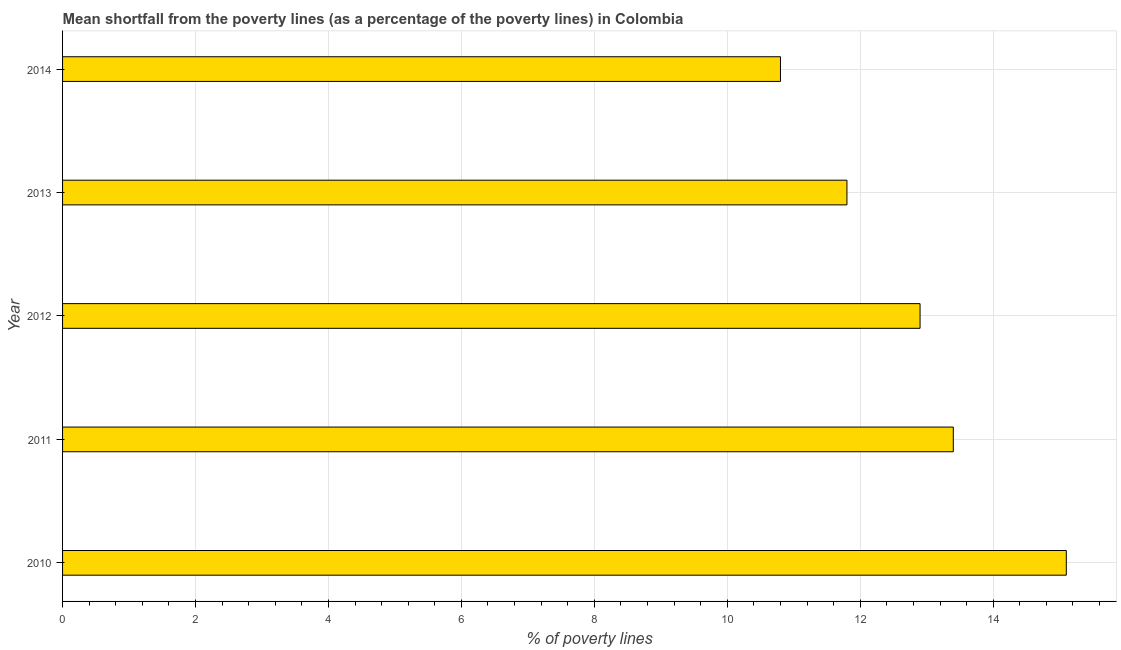What is the title of the graph?
Make the answer very short. Mean shortfall from the poverty lines (as a percentage of the poverty lines) in Colombia. What is the label or title of the X-axis?
Your response must be concise. % of poverty lines. What is the poverty gap at national poverty lines in 2012?
Ensure brevity in your answer.  12.9. In which year was the poverty gap at national poverty lines maximum?
Make the answer very short. 2010. What is the sum of the poverty gap at national poverty lines?
Keep it short and to the point. 64. What is the difference between the poverty gap at national poverty lines in 2012 and 2013?
Offer a terse response. 1.1. What is the average poverty gap at national poverty lines per year?
Give a very brief answer. 12.8. Do a majority of the years between 2010 and 2013 (inclusive) have poverty gap at national poverty lines greater than 3.6 %?
Offer a terse response. Yes. What is the ratio of the poverty gap at national poverty lines in 2011 to that in 2014?
Give a very brief answer. 1.24. What is the difference between the highest and the second highest poverty gap at national poverty lines?
Your answer should be very brief. 1.7. Is the sum of the poverty gap at national poverty lines in 2010 and 2011 greater than the maximum poverty gap at national poverty lines across all years?
Your answer should be compact. Yes. What is the difference between the highest and the lowest poverty gap at national poverty lines?
Give a very brief answer. 4.3. How many bars are there?
Provide a succinct answer. 5. How many years are there in the graph?
Provide a succinct answer. 5. What is the % of poverty lines in 2011?
Provide a succinct answer. 13.4. What is the % of poverty lines of 2012?
Your response must be concise. 12.9. What is the difference between the % of poverty lines in 2010 and 2012?
Your response must be concise. 2.2. What is the difference between the % of poverty lines in 2010 and 2014?
Ensure brevity in your answer.  4.3. What is the difference between the % of poverty lines in 2011 and 2012?
Your response must be concise. 0.5. What is the difference between the % of poverty lines in 2011 and 2013?
Your response must be concise. 1.6. What is the difference between the % of poverty lines in 2012 and 2014?
Offer a very short reply. 2.1. What is the ratio of the % of poverty lines in 2010 to that in 2011?
Your answer should be compact. 1.13. What is the ratio of the % of poverty lines in 2010 to that in 2012?
Your response must be concise. 1.17. What is the ratio of the % of poverty lines in 2010 to that in 2013?
Your answer should be compact. 1.28. What is the ratio of the % of poverty lines in 2010 to that in 2014?
Keep it short and to the point. 1.4. What is the ratio of the % of poverty lines in 2011 to that in 2012?
Provide a short and direct response. 1.04. What is the ratio of the % of poverty lines in 2011 to that in 2013?
Offer a terse response. 1.14. What is the ratio of the % of poverty lines in 2011 to that in 2014?
Your response must be concise. 1.24. What is the ratio of the % of poverty lines in 2012 to that in 2013?
Ensure brevity in your answer.  1.09. What is the ratio of the % of poverty lines in 2012 to that in 2014?
Provide a succinct answer. 1.19. What is the ratio of the % of poverty lines in 2013 to that in 2014?
Keep it short and to the point. 1.09. 